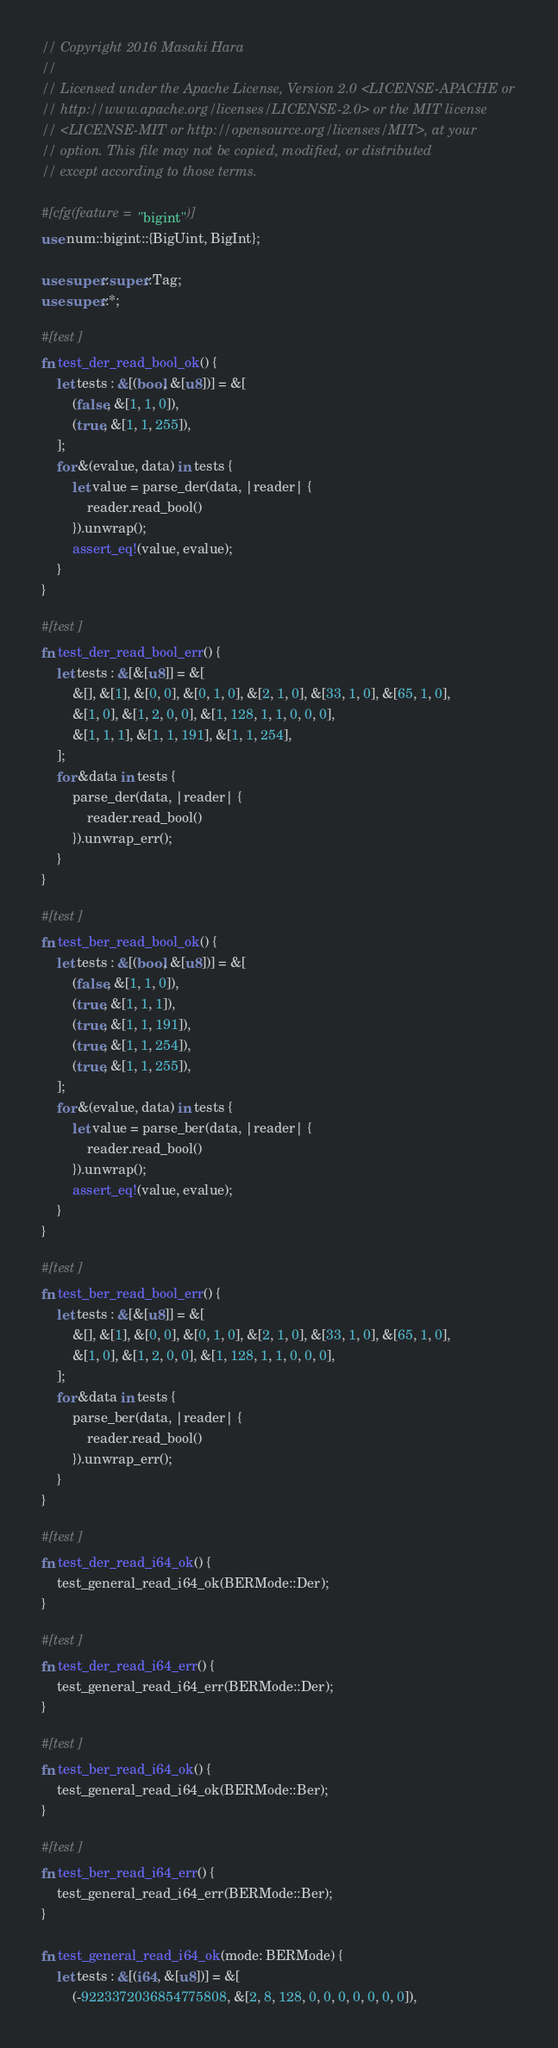<code> <loc_0><loc_0><loc_500><loc_500><_Rust_>// Copyright 2016 Masaki Hara
//
// Licensed under the Apache License, Version 2.0 <LICENSE-APACHE or
// http://www.apache.org/licenses/LICENSE-2.0> or the MIT license
// <LICENSE-MIT or http://opensource.org/licenses/MIT>, at your
// option. This file may not be copied, modified, or distributed
// except according to those terms.

#[cfg(feature = "bigint")]
use num::bigint::{BigUint, BigInt};

use super::super::Tag;
use super::*;

#[test]
fn test_der_read_bool_ok() {
    let tests : &[(bool, &[u8])] = &[
        (false, &[1, 1, 0]),
        (true, &[1, 1, 255]),
    ];
    for &(evalue, data) in tests {
        let value = parse_der(data, |reader| {
            reader.read_bool()
        }).unwrap();
        assert_eq!(value, evalue);
    }
}

#[test]
fn test_der_read_bool_err() {
    let tests : &[&[u8]] = &[
        &[], &[1], &[0, 0], &[0, 1, 0], &[2, 1, 0], &[33, 1, 0], &[65, 1, 0],
        &[1, 0], &[1, 2, 0, 0], &[1, 128, 1, 1, 0, 0, 0],
        &[1, 1, 1], &[1, 1, 191], &[1, 1, 254],
    ];
    for &data in tests {
        parse_der(data, |reader| {
            reader.read_bool()
        }).unwrap_err();
    }
}

#[test]
fn test_ber_read_bool_ok() {
    let tests : &[(bool, &[u8])] = &[
        (false, &[1, 1, 0]),
        (true, &[1, 1, 1]),
        (true, &[1, 1, 191]),
        (true, &[1, 1, 254]),
        (true, &[1, 1, 255]),
    ];
    for &(evalue, data) in tests {
        let value = parse_ber(data, |reader| {
            reader.read_bool()
        }).unwrap();
        assert_eq!(value, evalue);
    }
}

#[test]
fn test_ber_read_bool_err() {
    let tests : &[&[u8]] = &[
        &[], &[1], &[0, 0], &[0, 1, 0], &[2, 1, 0], &[33, 1, 0], &[65, 1, 0],
        &[1, 0], &[1, 2, 0, 0], &[1, 128, 1, 1, 0, 0, 0],
    ];
    for &data in tests {
        parse_ber(data, |reader| {
            reader.read_bool()
        }).unwrap_err();
    }
}

#[test]
fn test_der_read_i64_ok() {
    test_general_read_i64_ok(BERMode::Der);
}

#[test]
fn test_der_read_i64_err() {
    test_general_read_i64_err(BERMode::Der);
}

#[test]
fn test_ber_read_i64_ok() {
    test_general_read_i64_ok(BERMode::Ber);
}

#[test]
fn test_ber_read_i64_err() {
    test_general_read_i64_err(BERMode::Ber);
}

fn test_general_read_i64_ok(mode: BERMode) {
    let tests : &[(i64, &[u8])] = &[
        (-9223372036854775808, &[2, 8, 128, 0, 0, 0, 0, 0, 0, 0]),</code> 